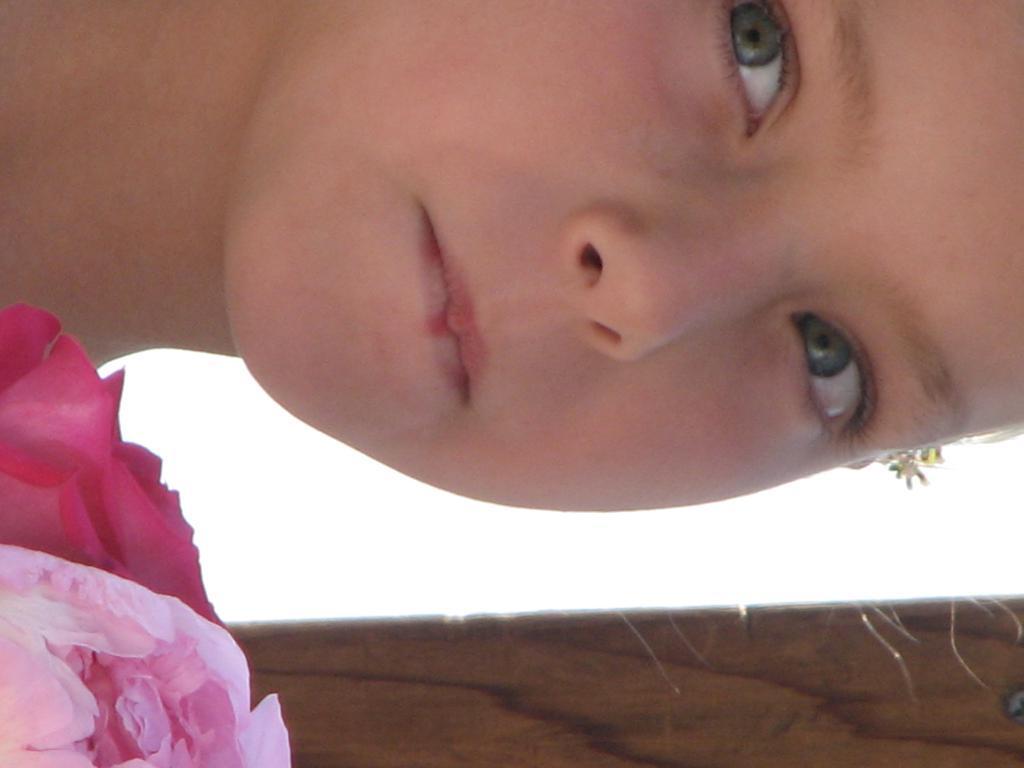Please provide a concise description of this image. In this picture I can see in the bottom left hand side there is a cloth, at the top there is a person. 